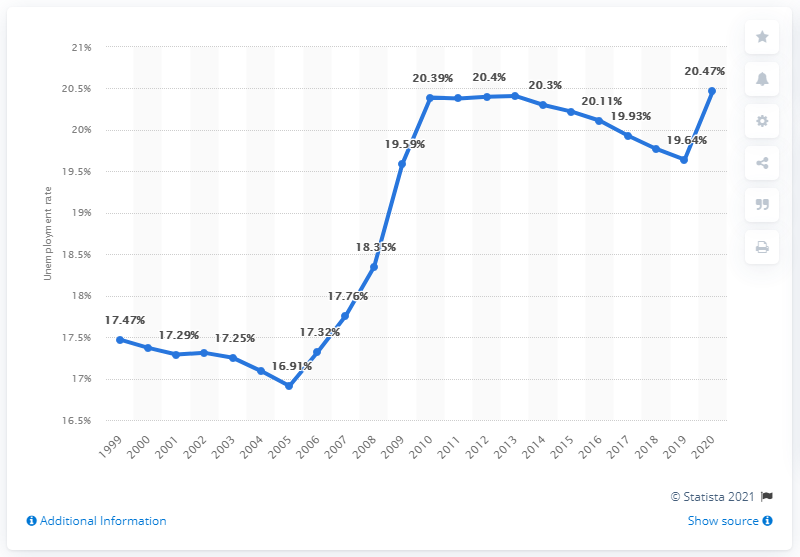Specify some key components in this picture. In 2020, the unemployment rate in Gabon was 20.47%. 